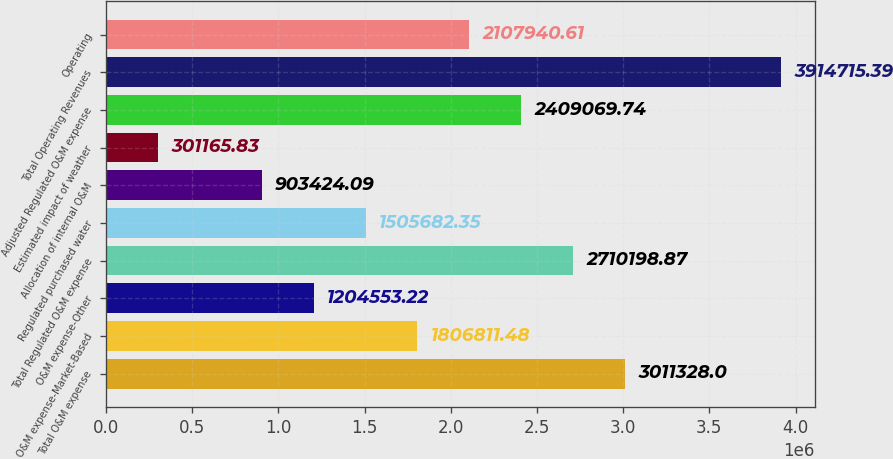Convert chart. <chart><loc_0><loc_0><loc_500><loc_500><bar_chart><fcel>Total O&M expense<fcel>O&M expense-Market-Based<fcel>O&M expense-Other<fcel>Total Regulated O&M expense<fcel>Regulated purchased water<fcel>Allocation of internal O&M<fcel>Estimated impact of weather<fcel>Adjusted Regulated O&M expense<fcel>Total Operating Revenues<fcel>Operating<nl><fcel>3.01133e+06<fcel>1.80681e+06<fcel>1.20455e+06<fcel>2.7102e+06<fcel>1.50568e+06<fcel>903424<fcel>301166<fcel>2.40907e+06<fcel>3.91472e+06<fcel>2.10794e+06<nl></chart> 